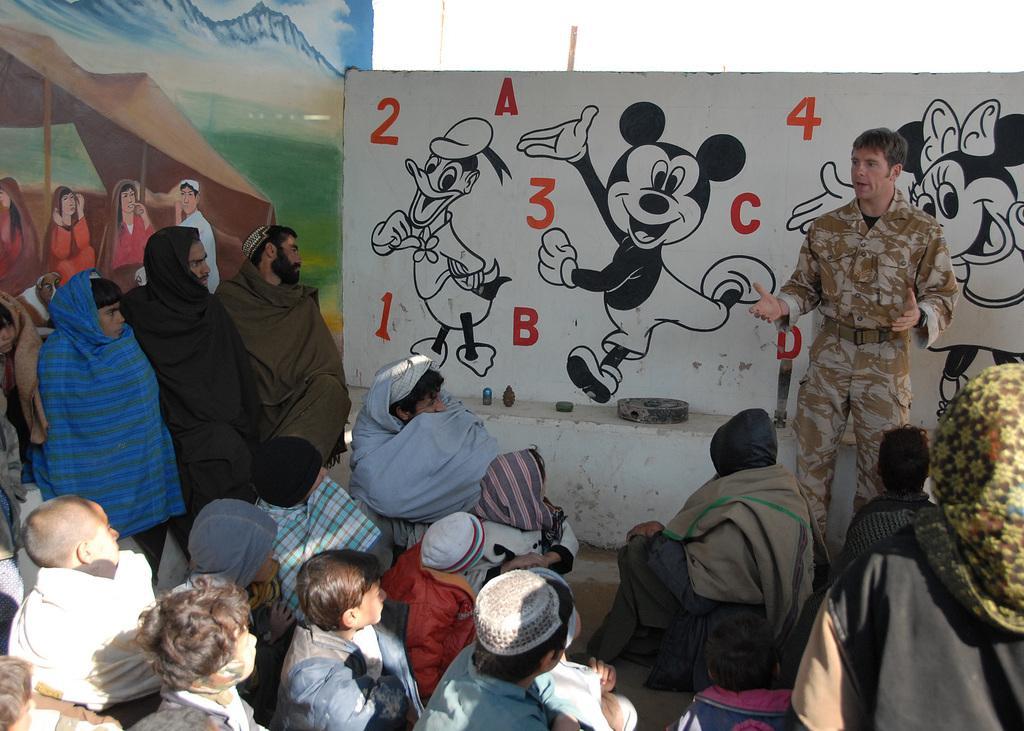How would you summarize this image in a sentence or two? In this image there are a few people sitting and some other people standing. Behind them there are walls with painting and letters on it. In front of the wall there are some objects on the platform. In the background of the image there is sky. 